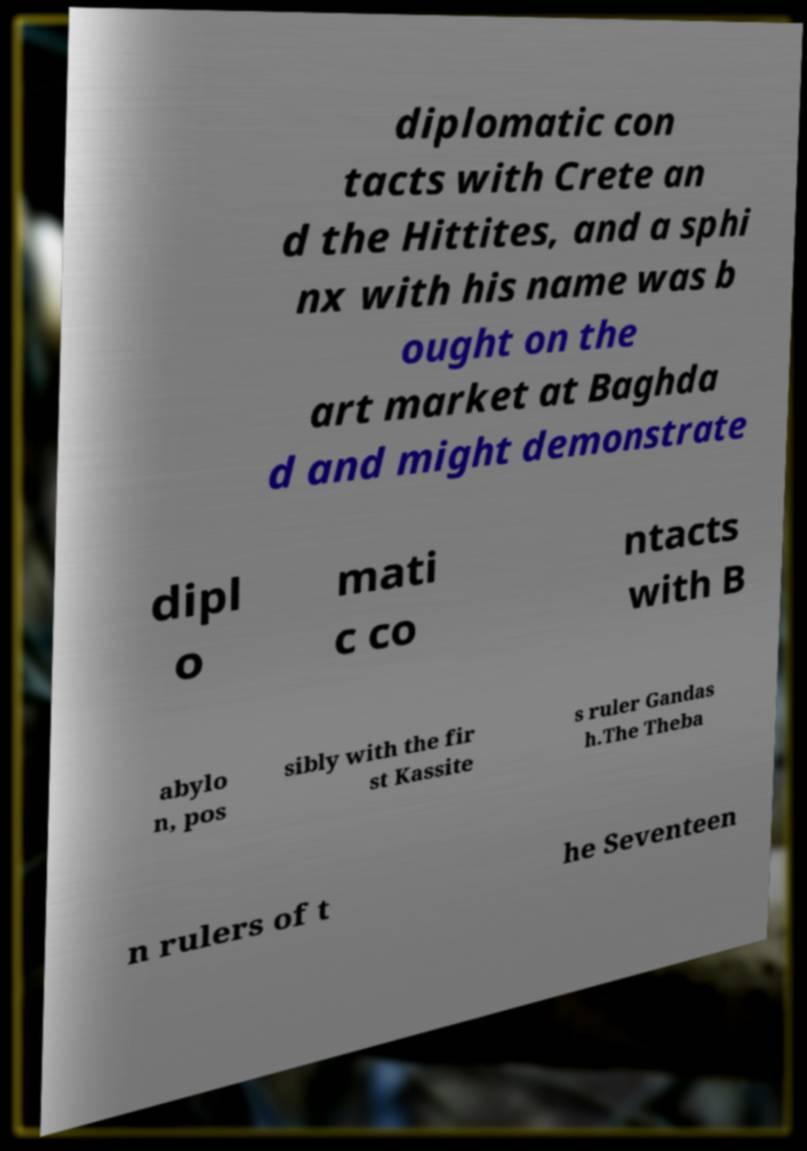Can you accurately transcribe the text from the provided image for me? diplomatic con tacts with Crete an d the Hittites, and a sphi nx with his name was b ought on the art market at Baghda d and might demonstrate dipl o mati c co ntacts with B abylo n, pos sibly with the fir st Kassite s ruler Gandas h.The Theba n rulers of t he Seventeen 